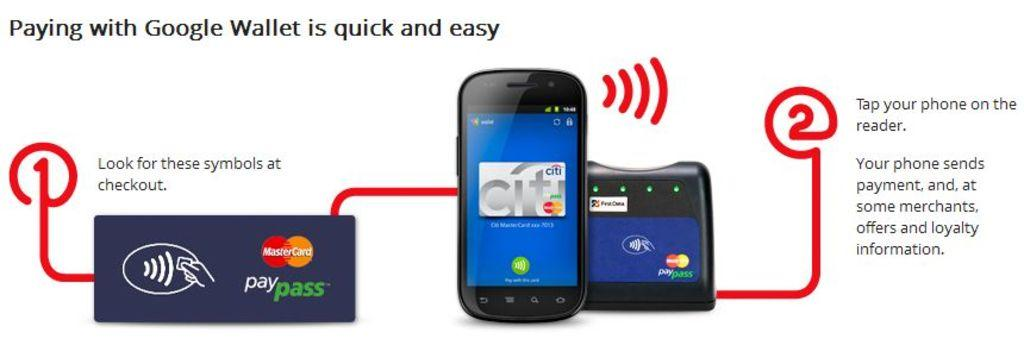<image>
Relay a brief, clear account of the picture shown. A phone with paypass on it next to it 